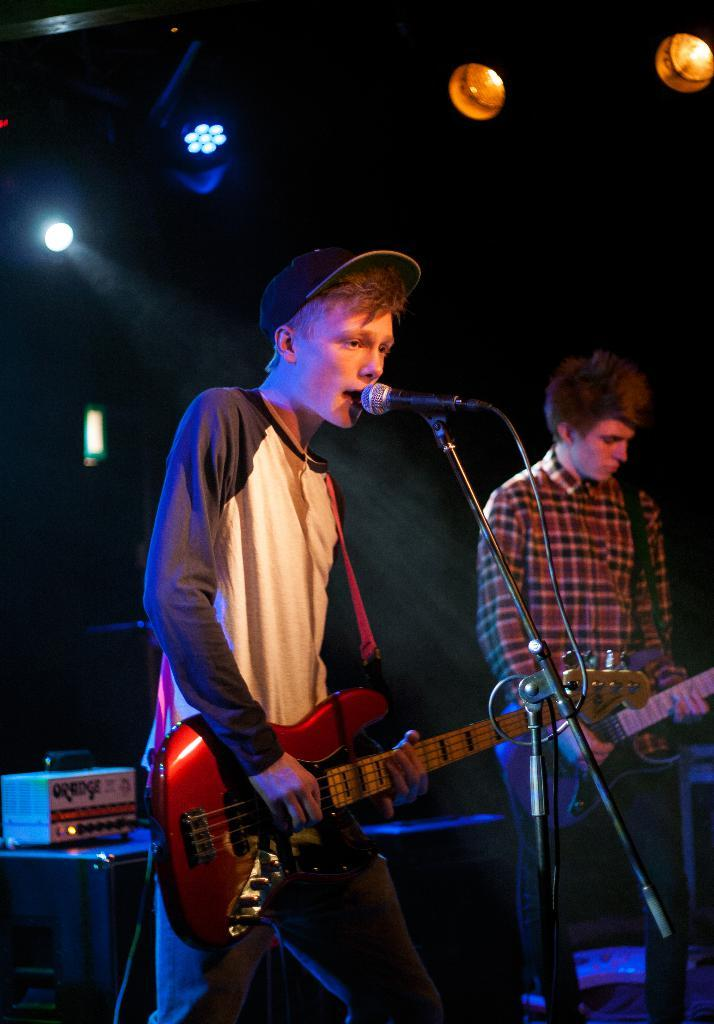How many people are in the image? There are two persons in the image. What are the two persons doing in the image? The two persons are playing guitar. What object is present for amplifying their voices? There is a microphone in the image. What can be seen in the background of the image? There are electronic devices in the background of the image. What is visible at the top of the image? There are lights visible at the top of the image. How many cats are sitting on the volcano in the image? There are no cats or volcanoes present in the image. 